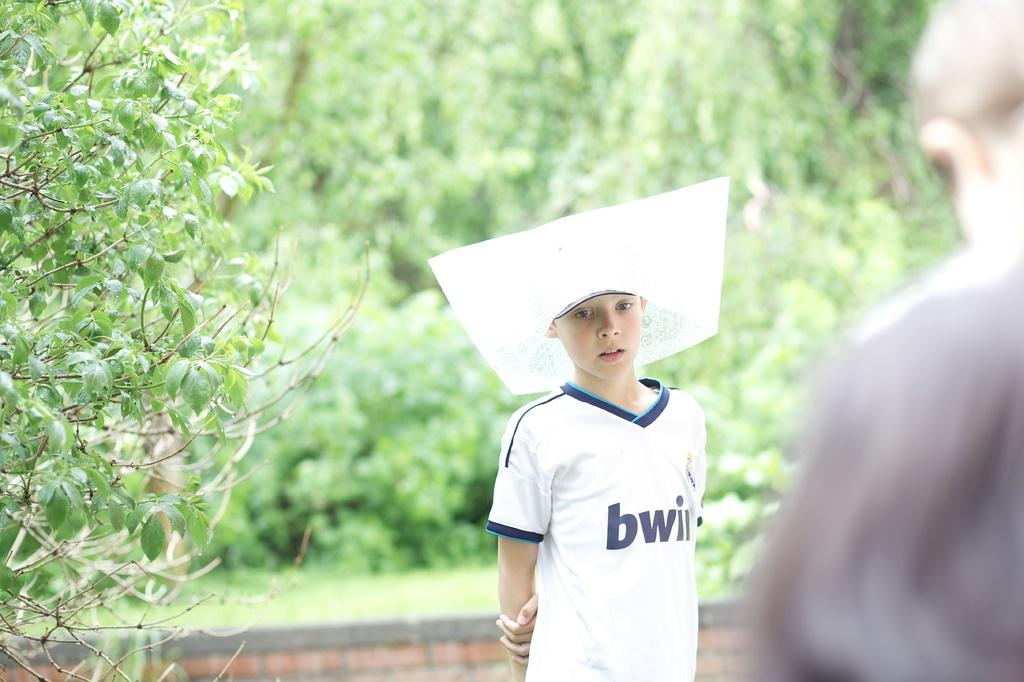<image>
Offer a succinct explanation of the picture presented. A child wearing a white square shaped head piece and white V-neck shirt with the letters bwi on the chest. 